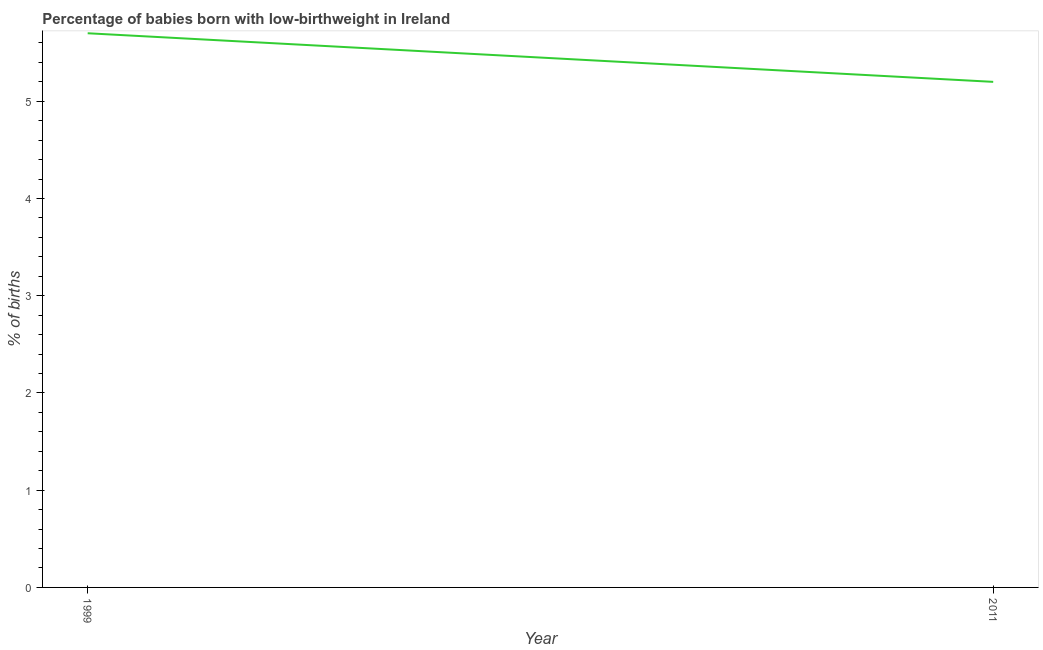Across all years, what is the maximum percentage of babies who were born with low-birthweight?
Provide a short and direct response. 5.7. What is the sum of the percentage of babies who were born with low-birthweight?
Provide a succinct answer. 10.9. What is the average percentage of babies who were born with low-birthweight per year?
Your answer should be very brief. 5.45. What is the median percentage of babies who were born with low-birthweight?
Ensure brevity in your answer.  5.45. In how many years, is the percentage of babies who were born with low-birthweight greater than 2.8 %?
Your answer should be very brief. 2. What is the ratio of the percentage of babies who were born with low-birthweight in 1999 to that in 2011?
Your response must be concise. 1.1. Is the percentage of babies who were born with low-birthweight in 1999 less than that in 2011?
Your answer should be compact. No. Does the percentage of babies who were born with low-birthweight monotonically increase over the years?
Your answer should be very brief. No. How many lines are there?
Keep it short and to the point. 1. How many years are there in the graph?
Your answer should be very brief. 2. Are the values on the major ticks of Y-axis written in scientific E-notation?
Offer a very short reply. No. What is the title of the graph?
Offer a very short reply. Percentage of babies born with low-birthweight in Ireland. What is the label or title of the Y-axis?
Provide a succinct answer. % of births. What is the difference between the % of births in 1999 and 2011?
Offer a terse response. 0.5. What is the ratio of the % of births in 1999 to that in 2011?
Provide a short and direct response. 1.1. 